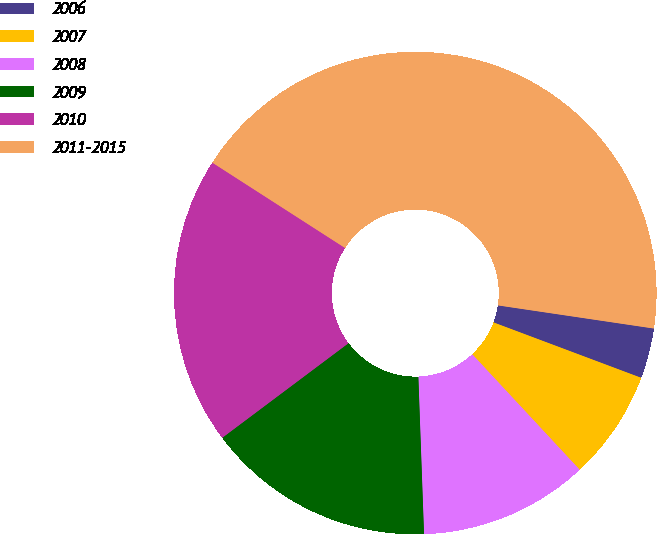<chart> <loc_0><loc_0><loc_500><loc_500><pie_chart><fcel>2006<fcel>2007<fcel>2008<fcel>2009<fcel>2010<fcel>2011-2015<nl><fcel>3.37%<fcel>7.36%<fcel>11.35%<fcel>15.34%<fcel>19.33%<fcel>43.25%<nl></chart> 